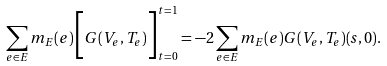Convert formula to latex. <formula><loc_0><loc_0><loc_500><loc_500>\sum _ { e \in E } m _ { E } ( e ) \Big { [ } G ( V _ { e } , T _ { e } ) \Big { ] } _ { t = 0 } ^ { t = 1 } = - 2 \sum _ { e \in E } m _ { E } ( e ) G ( V _ { e } , T _ { e } ) ( s , 0 ) .</formula> 